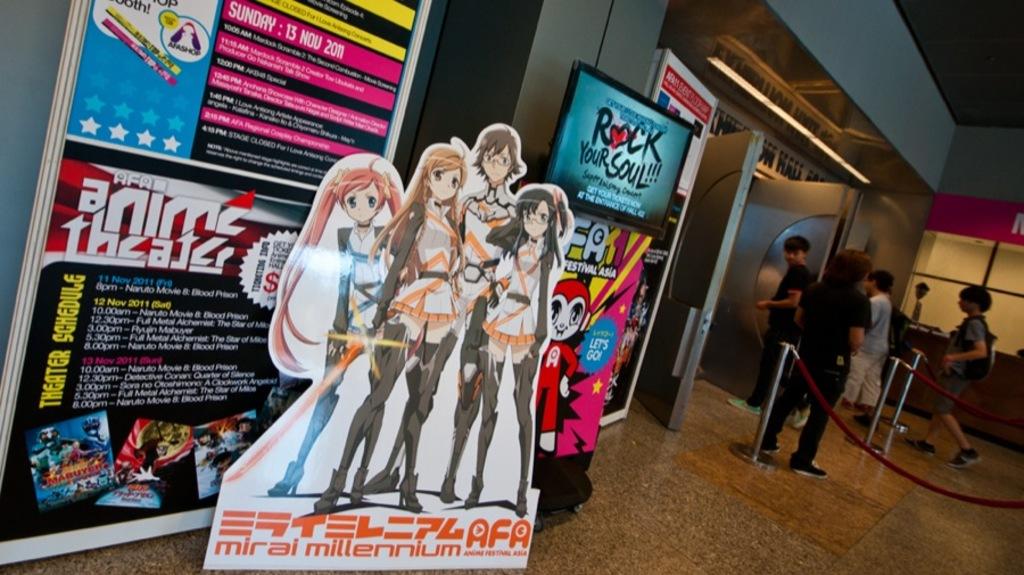What is the name of the anime?
Give a very brief answer. Mirai millennium. What does the sign on the right with the blue background say?
Make the answer very short. Rock your soul. 